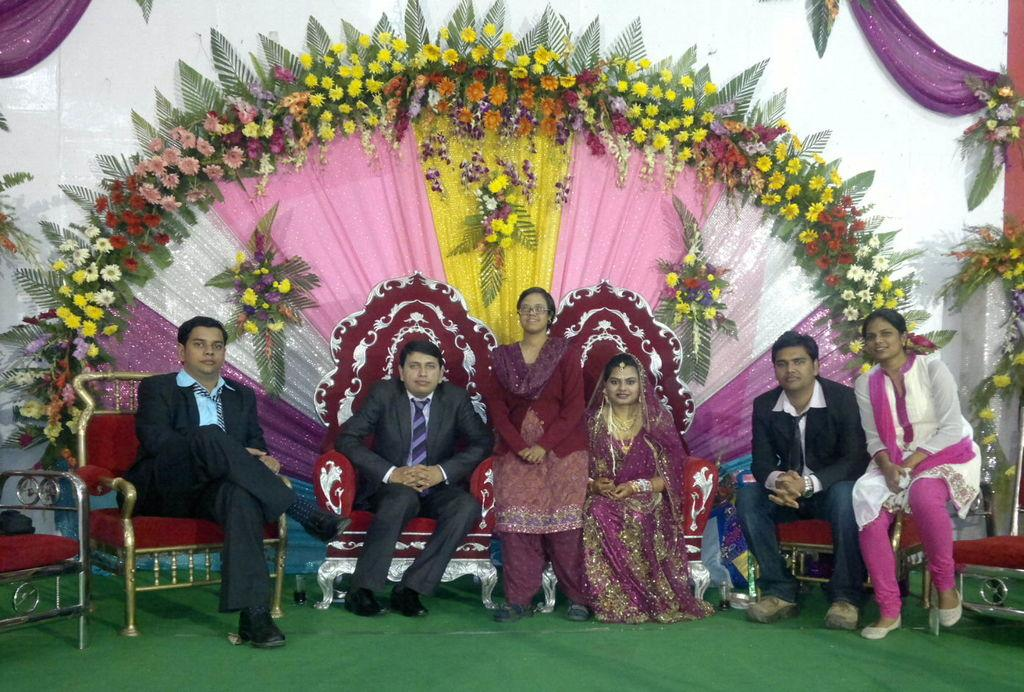How many people are in the image? There are seven persons in the image. Where are the persons sitting? The persons are sitting on a dais. What is at the bottom of the image? There is a green carpet at the bottom of the image. What can be seen in the background of the image? There are many flowers and clothes visible in the background of the image. What type of arm is visible in the image? There is no arm present in the image. Are the persons wearing stockings in the image? The provided facts do not mention anything about stockings, so it cannot be determined from the image. 